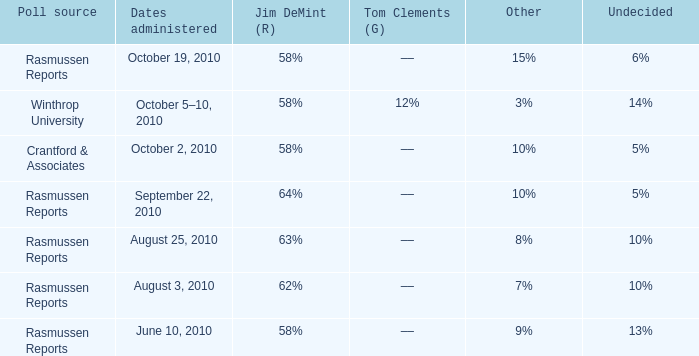What was the vote for Alvin Green when other was 9%? 21%. 